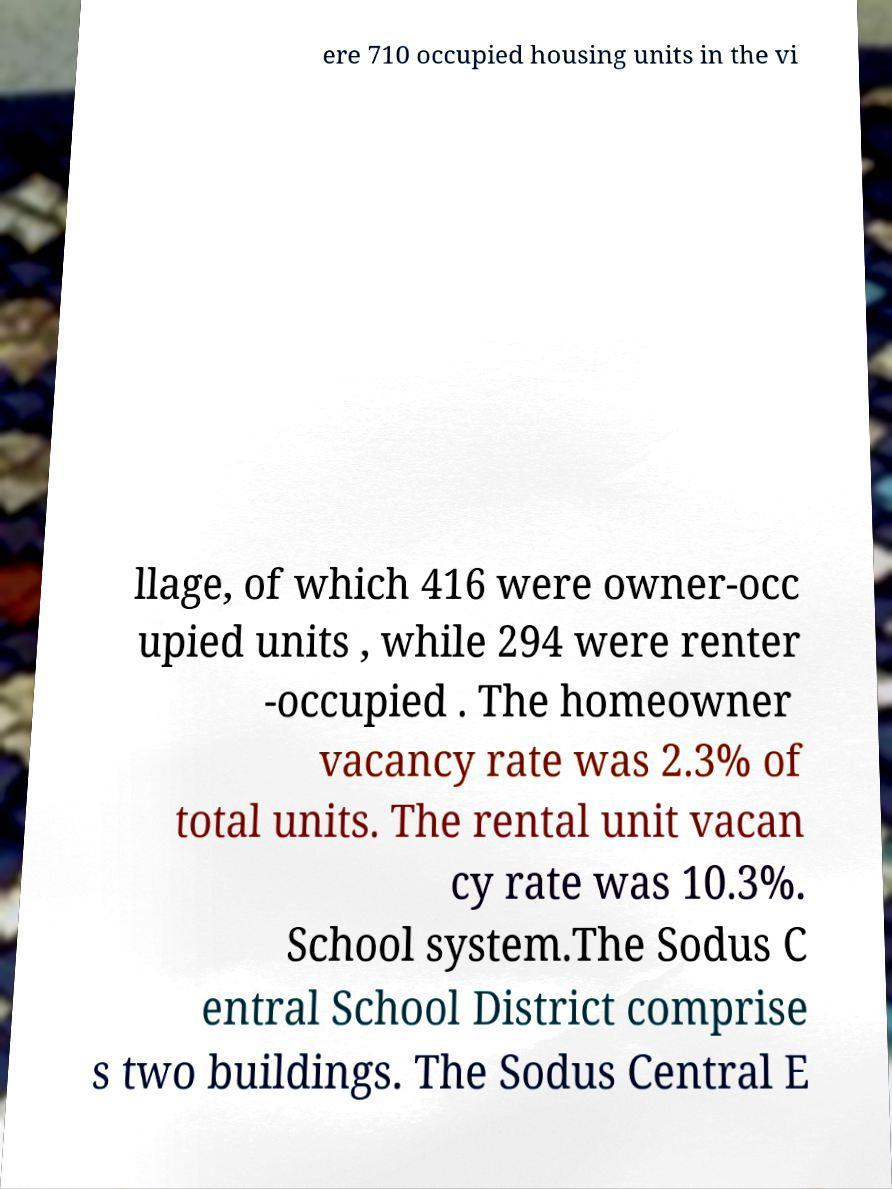Please identify and transcribe the text found in this image. ere 710 occupied housing units in the vi llage, of which 416 were owner-occ upied units , while 294 were renter -occupied . The homeowner vacancy rate was 2.3% of total units. The rental unit vacan cy rate was 10.3%. School system.The Sodus C entral School District comprise s two buildings. The Sodus Central E 